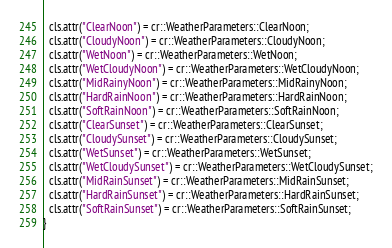Convert code to text. <code><loc_0><loc_0><loc_500><loc_500><_C++_>
  cls.attr("ClearNoon") = cr::WeatherParameters::ClearNoon;
  cls.attr("CloudyNoon") = cr::WeatherParameters::CloudyNoon;
  cls.attr("WetNoon") = cr::WeatherParameters::WetNoon;
  cls.attr("WetCloudyNoon") = cr::WeatherParameters::WetCloudyNoon;
  cls.attr("MidRainyNoon") = cr::WeatherParameters::MidRainyNoon;
  cls.attr("HardRainNoon") = cr::WeatherParameters::HardRainNoon;
  cls.attr("SoftRainNoon") = cr::WeatherParameters::SoftRainNoon;
  cls.attr("ClearSunset") = cr::WeatherParameters::ClearSunset;
  cls.attr("CloudySunset") = cr::WeatherParameters::CloudySunset;
  cls.attr("WetSunset") = cr::WeatherParameters::WetSunset;
  cls.attr("WetCloudySunset") = cr::WeatherParameters::WetCloudySunset;
  cls.attr("MidRainSunset") = cr::WeatherParameters::MidRainSunset;
  cls.attr("HardRainSunset") = cr::WeatherParameters::HardRainSunset;
  cls.attr("SoftRainSunset") = cr::WeatherParameters::SoftRainSunset;
}
</code> 